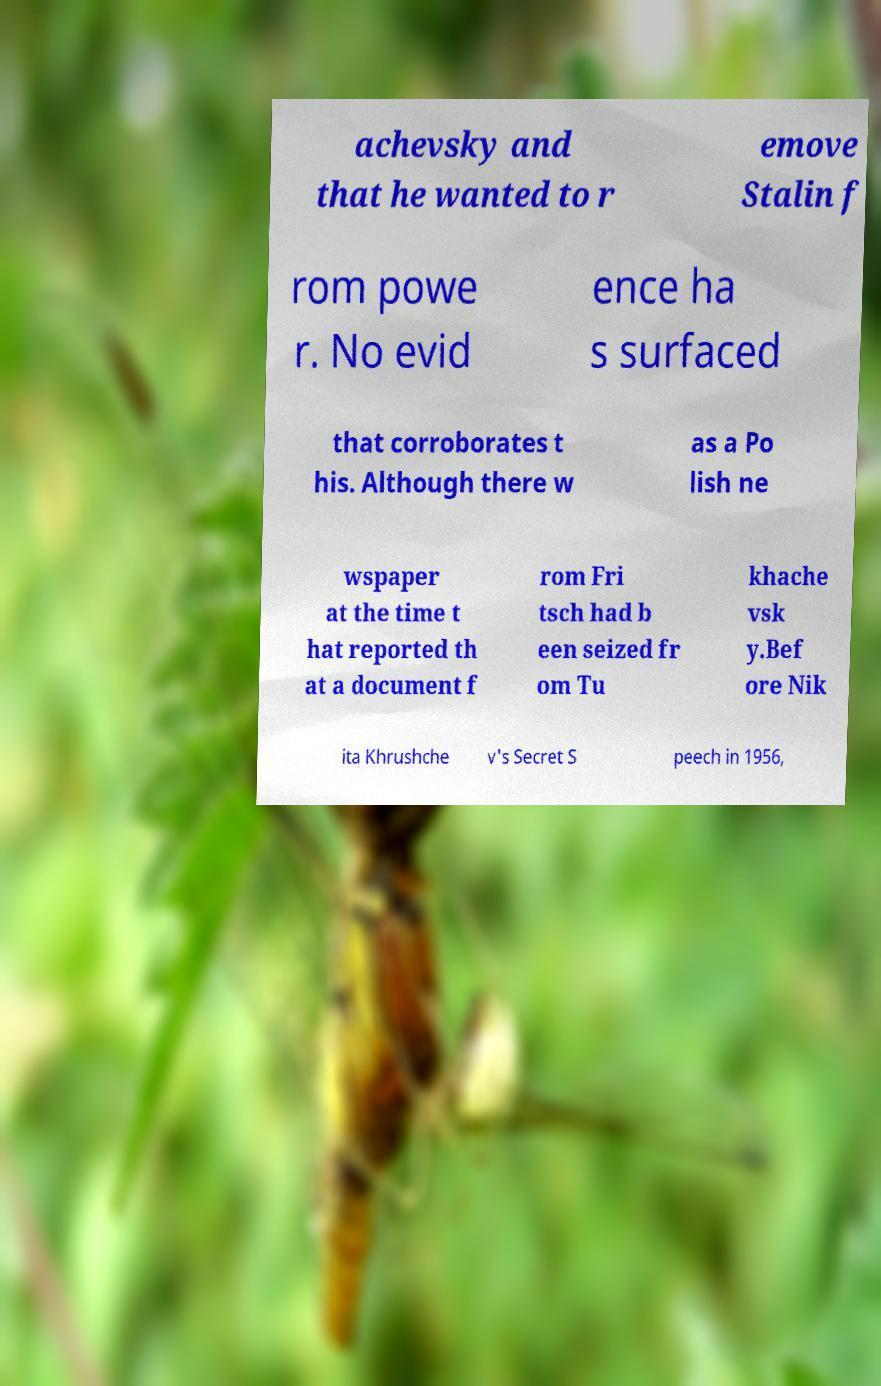There's text embedded in this image that I need extracted. Can you transcribe it verbatim? achevsky and that he wanted to r emove Stalin f rom powe r. No evid ence ha s surfaced that corroborates t his. Although there w as a Po lish ne wspaper at the time t hat reported th at a document f rom Fri tsch had b een seized fr om Tu khache vsk y.Bef ore Nik ita Khrushche v's Secret S peech in 1956, 